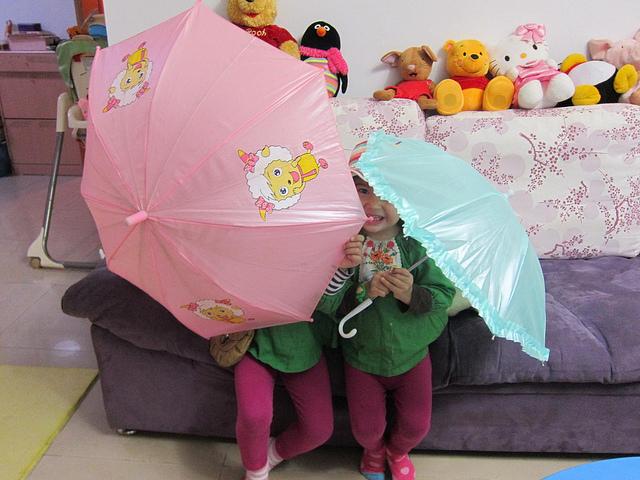What color is the sofa?
Give a very brief answer. Purple. Where is the Hello Kitty doll?
Keep it brief. On top of couch. Why are they holding umbrellas?
Write a very short answer. Playing. 